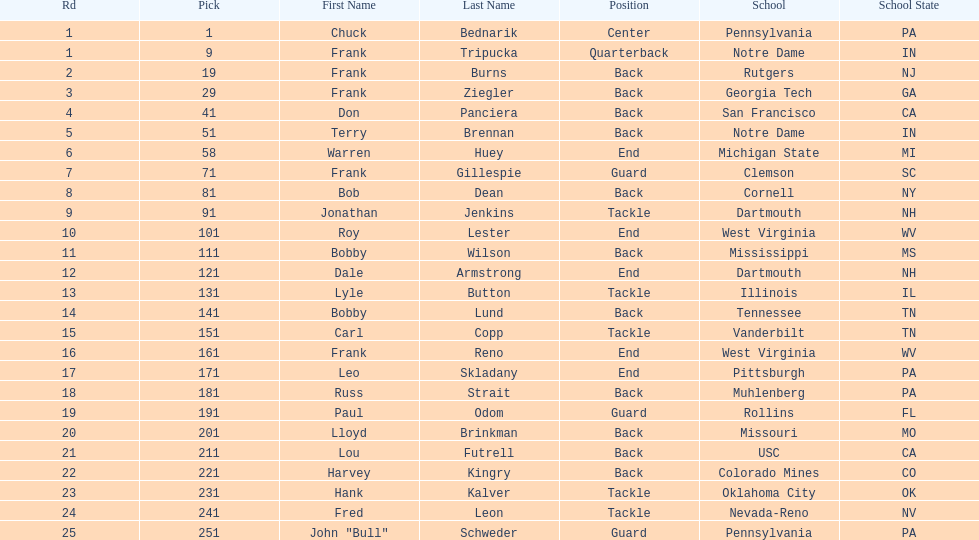Parse the full table. {'header': ['Rd', 'Pick', 'First Name', 'Last Name', 'Position', 'School', 'School State'], 'rows': [['1', '1', 'Chuck', 'Bednarik', 'Center', 'Pennsylvania', 'PA'], ['1', '9', 'Frank', 'Tripucka', 'Quarterback', 'Notre Dame', 'IN'], ['2', '19', 'Frank', 'Burns', 'Back', 'Rutgers', 'NJ'], ['3', '29', 'Frank', 'Ziegler', 'Back', 'Georgia Tech', 'GA'], ['4', '41', 'Don', 'Panciera', 'Back', 'San Francisco', 'CA'], ['5', '51', 'Terry', 'Brennan', 'Back', 'Notre Dame', 'IN'], ['6', '58', 'Warren', 'Huey', 'End', 'Michigan State', 'MI'], ['7', '71', 'Frank', 'Gillespie', 'Guard', 'Clemson', 'SC'], ['8', '81', 'Bob', 'Dean', 'Back', 'Cornell', 'NY'], ['9', '91', 'Jonathan', 'Jenkins', 'Tackle', 'Dartmouth', 'NH'], ['10', '101', 'Roy', 'Lester', 'End', 'West Virginia', 'WV'], ['11', '111', 'Bobby', 'Wilson', 'Back', 'Mississippi', 'MS'], ['12', '121', 'Dale', 'Armstrong', 'End', 'Dartmouth', 'NH'], ['13', '131', 'Lyle', 'Button', 'Tackle', 'Illinois', 'IL'], ['14', '141', 'Bobby', 'Lund', 'Back', 'Tennessee', 'TN'], ['15', '151', 'Carl', 'Copp', 'Tackle', 'Vanderbilt', 'TN'], ['16', '161', 'Frank', 'Reno', 'End', 'West Virginia', 'WV'], ['17', '171', 'Leo', 'Skladany', 'End', 'Pittsburgh', 'PA'], ['18', '181', 'Russ', 'Strait', 'Back', 'Muhlenberg', 'PA'], ['19', '191', 'Paul', 'Odom', 'Guard', 'Rollins', 'FL'], ['20', '201', 'Lloyd', 'Brinkman', 'Back', 'Missouri', 'MO'], ['21', '211', 'Lou', 'Futrell', 'Back', 'USC', 'CA'], ['22', '221', 'Harvey', 'Kingry', 'Back', 'Colorado Mines', 'CO'], ['23', '231', 'Hank', 'Kalver', 'Tackle', 'Oklahoma City', 'OK'], ['24', '241', 'Fred', 'Leon', 'Tackle', 'Nevada-Reno', 'NV'], ['25', '251', 'John "Bull"', 'Schweder', 'Guard', 'Pennsylvania', 'PA']]} Who was the player that the team drafted after bob dean? Jonathan Jenkins. 